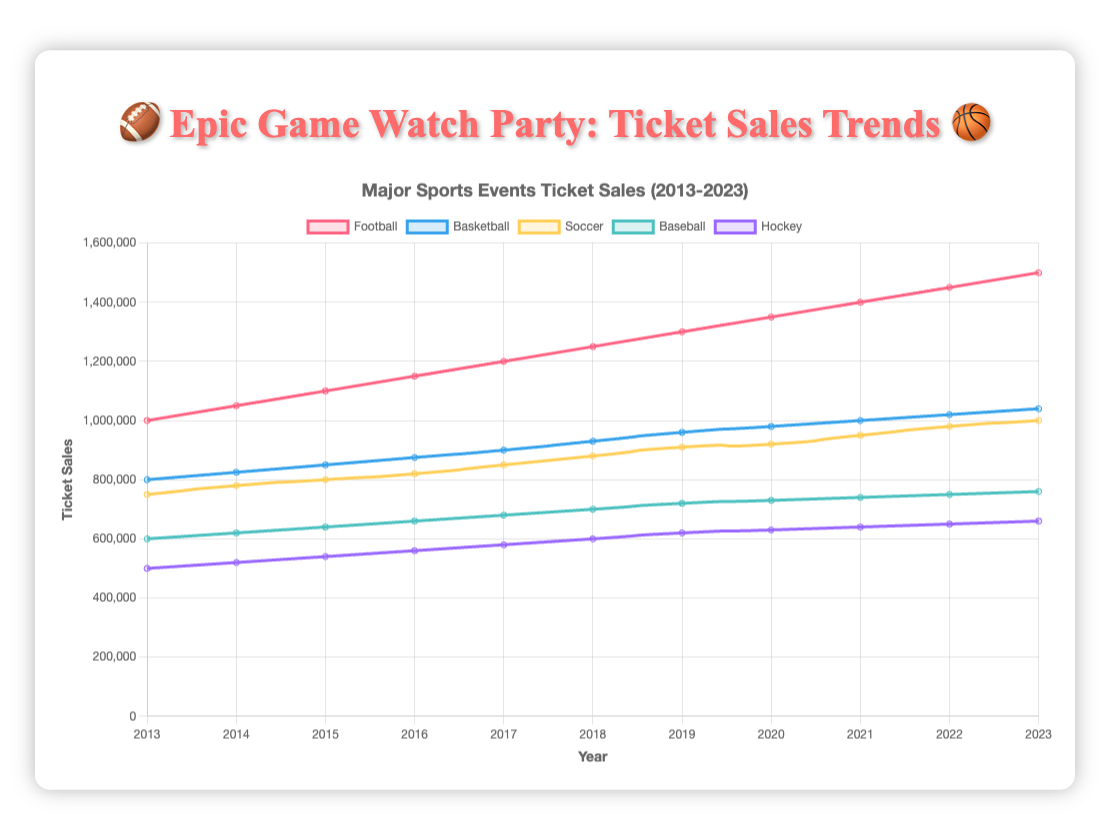Which sport saw the highest ticket sales in 2023? In 2023, the data points for ticket sales are: Football (1,500,000), Basketball (1,040,000), Soccer (1,000,000), Baseball (760,000), and Hockey (660,000). Football has the highest value.
Answer: Football What is the overall trend for football ticket sales from 2013 to 2023? The football ticket sales data from 2013 to 2023 show a continuous increase each year, starting at 1,000,000 in 2013 and reaching 1,500,000 in 2023.
Answer: Increasing Which sport had the smallest growth in ticket sales between 2013 and 2023? To determine the smallest growth, subtract the 2013 ticket sales from the 2023 ticket sales for each sport: Football (1,500,000 - 1,000,000 = 500,000), Basketball (1,040,000 - 800,000 = 240,000), Soccer (1,000,000 - 750,000 = 250,000), Baseball (760,000 - 600,000 = 160,000), Hockey (660,000 - 500,000 = 160,000). Baseball and Hockey both had the smallest growth of 160,000.
Answer: Hockey/Baseball In which year did basketball first exceed 1,000,000 in ticket sales? Basketball ticket sales exceeded 1,000,000 for the first time in 2021 with 1,000,000 sales exactly.
Answer: 2021 Which two sports had ticket sales closest to each other in 2023? The sales in 2023 are: Football (1,500,000), Basketball (1,040,000), Soccer (1,000,000), Baseball (760,000), Hockey (660,000). The smallest difference is between Soccer (1,000,000) and Basketball (1,040,000) which is 40,000.
Answer: Basketball and Soccer By how much have soccer ticket sales increased from 2013 to 2023? Subtract the 2013 sales (750,000) from the 2023 sales (1,000,000) for soccer: 1,000,000 - 750,000 = 250,000
Answer: 250,000 Which sport had the most consistent yearly growth in ticket sales over the decade? Consistency can be checked by observing the year-over-year changes. Football (+50,000 each year), Basketball (+25,000 to +40,000 each year), Soccer (+20,000 to +30,000 each year), Baseball (+20,000 each year), Hockey (+20,000 each year). Football has the most uniform growth of +50,000 each year.
Answer: Football If the trends continued, what would be the expected football ticket sales in 2024? Football shows a consistent annual increase of 50,000 tickets. Adding this to the 2023 value gives 1,500,000 + 50,000 = 1,550,000.
Answer: 1,550,000 In 2018, which sport had ticket sales nearly equal to soccer's ticket sales in the same year? Soccer's ticket sales in 2018 were 880,000. Basketball sales were 930,000 which is the closest.
Answer: Basketball 